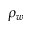Convert formula to latex. <formula><loc_0><loc_0><loc_500><loc_500>\rho _ { w }</formula> 